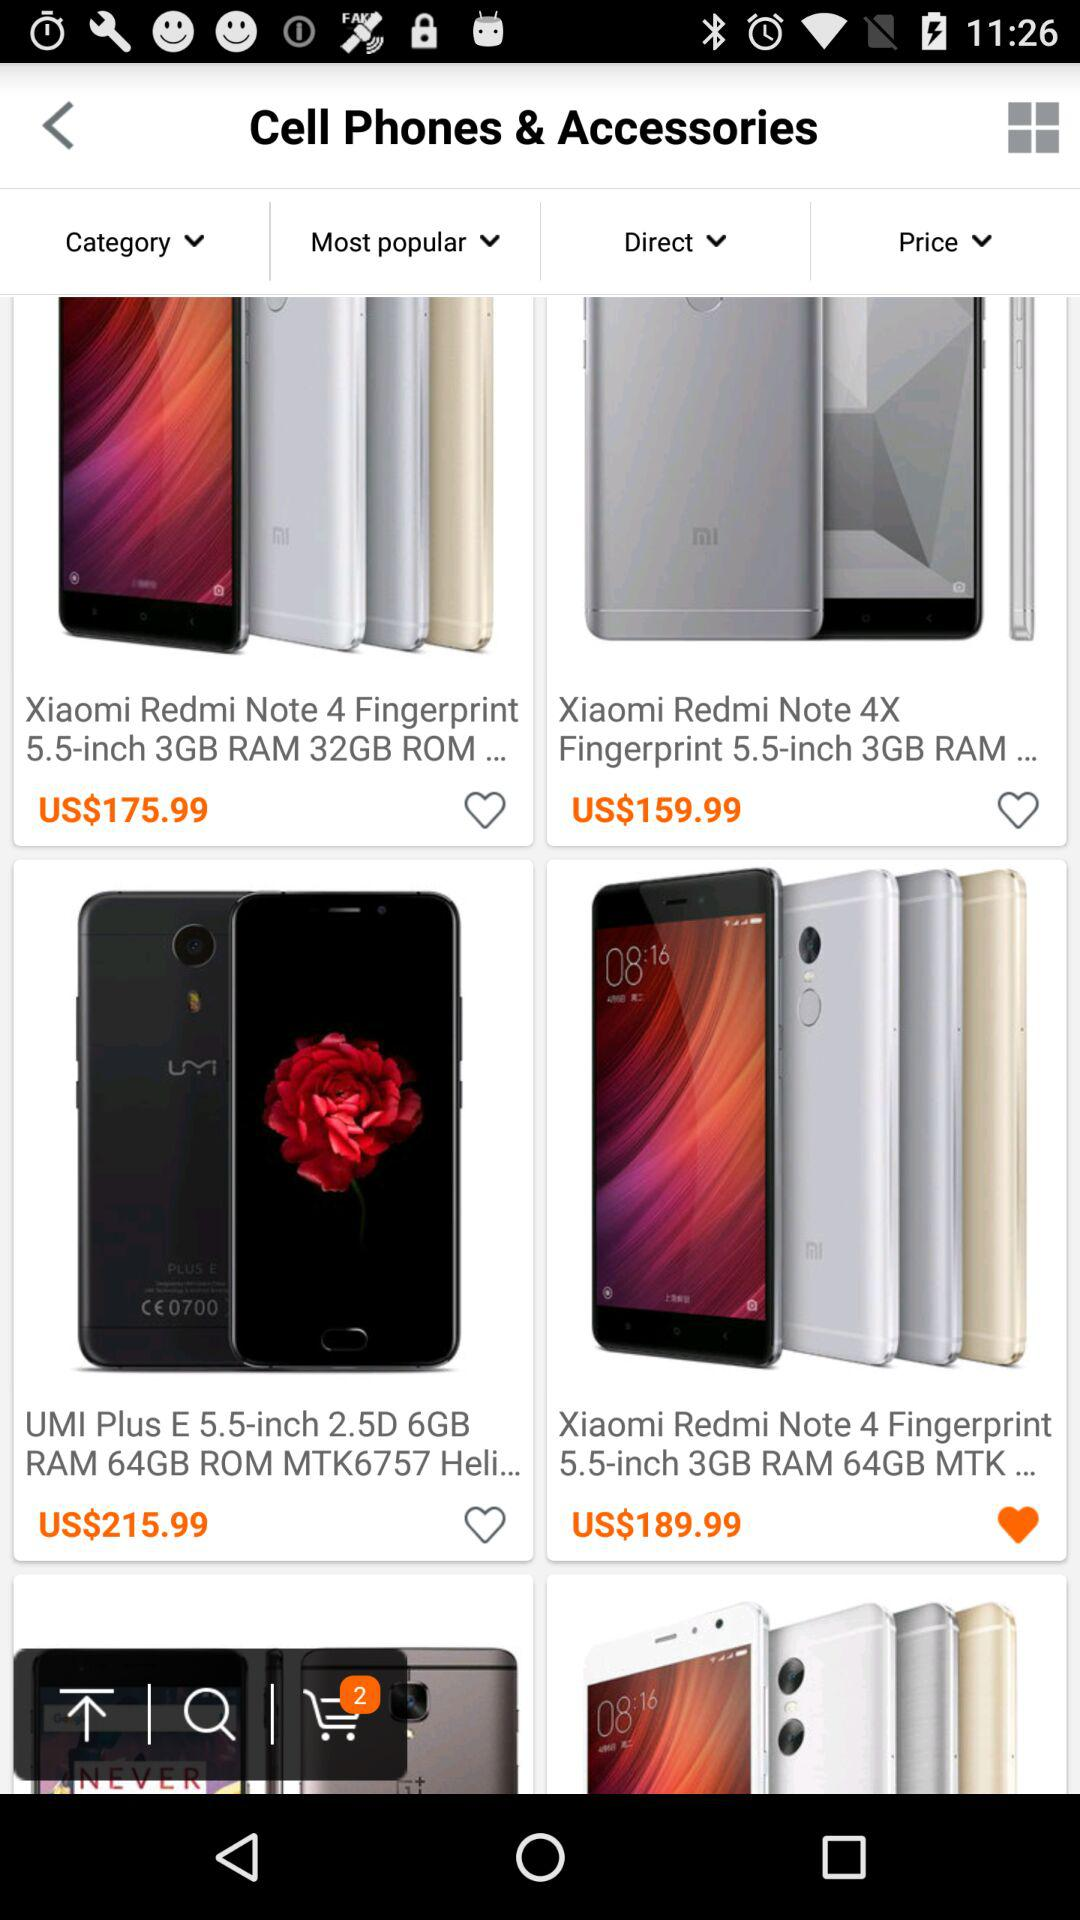What is the price of the "UMI Plus E 5.5-inch 2.5D 6GB RAM 64GB ROM MTK6757"? The price of the "UMI Plus E 5.5-inch 2.5D 6GB RAM 64GB ROM MTK6757" is US$215.99. 